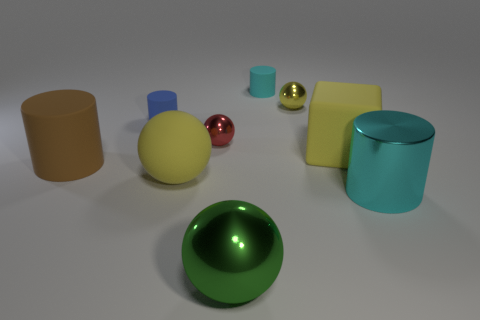Is there anything else that is the same color as the matte block?
Ensure brevity in your answer.  Yes. How many other objects are there of the same size as the green metallic sphere?
Give a very brief answer. 4. What is the material of the large cylinder that is behind the big yellow thing that is left of the big metallic object that is to the left of the large cyan cylinder?
Keep it short and to the point. Rubber. Is the material of the red sphere the same as the large yellow object that is in front of the big brown cylinder?
Ensure brevity in your answer.  No. Are there fewer green metal objects behind the metal cylinder than blue rubber objects that are in front of the brown matte thing?
Provide a succinct answer. No. What number of big yellow objects are made of the same material as the large cube?
Your response must be concise. 1. There is a shiny ball that is in front of the big cylinder to the left of the big cube; is there a small blue matte thing right of it?
Provide a succinct answer. No. What number of cylinders are cyan metal objects or blue things?
Offer a terse response. 2. Do the blue object and the big yellow matte object that is in front of the matte block have the same shape?
Offer a terse response. No. Are there fewer yellow shiny things to the right of the red ball than large red matte cylinders?
Give a very brief answer. No. 